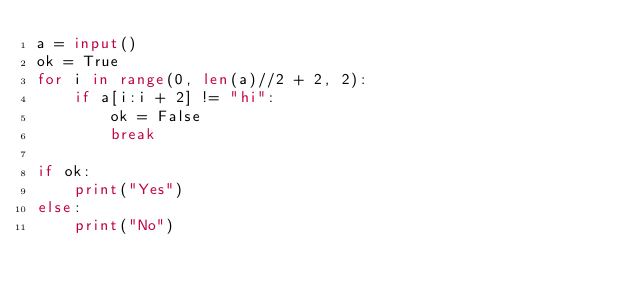<code> <loc_0><loc_0><loc_500><loc_500><_Python_>a = input()
ok = True
for i in range(0, len(a)//2 + 2, 2):
    if a[i:i + 2] != "hi":
        ok = False
        break

if ok:
    print("Yes")
else:
    print("No")</code> 